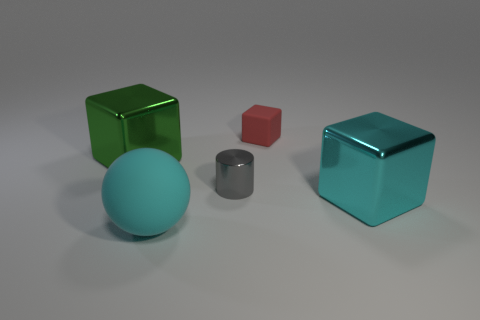What number of other objects are the same color as the small matte object? There are no other objects that share the same color as the small matte cylinder in the image. It's unique in its gray hue among the objects present. 